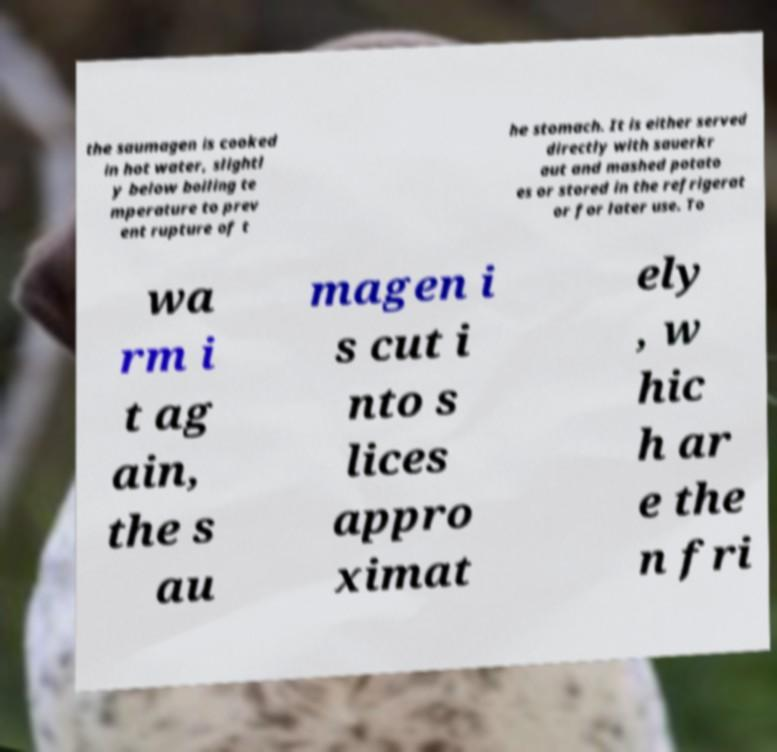Could you assist in decoding the text presented in this image and type it out clearly? the saumagen is cooked in hot water, slightl y below boiling te mperature to prev ent rupture of t he stomach. It is either served directly with sauerkr aut and mashed potato es or stored in the refrigerat or for later use. To wa rm i t ag ain, the s au magen i s cut i nto s lices appro ximat ely , w hic h ar e the n fri 